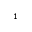Convert formula to latex. <formula><loc_0><loc_0><loc_500><loc_500>^ { 1 }</formula> 